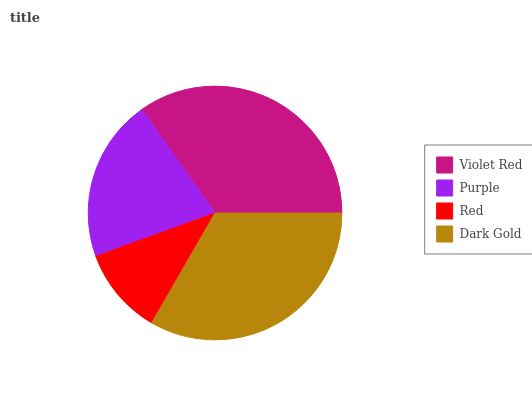Is Red the minimum?
Answer yes or no. Yes. Is Violet Red the maximum?
Answer yes or no. Yes. Is Purple the minimum?
Answer yes or no. No. Is Purple the maximum?
Answer yes or no. No. Is Violet Red greater than Purple?
Answer yes or no. Yes. Is Purple less than Violet Red?
Answer yes or no. Yes. Is Purple greater than Violet Red?
Answer yes or no. No. Is Violet Red less than Purple?
Answer yes or no. No. Is Dark Gold the high median?
Answer yes or no. Yes. Is Purple the low median?
Answer yes or no. Yes. Is Red the high median?
Answer yes or no. No. Is Violet Red the low median?
Answer yes or no. No. 